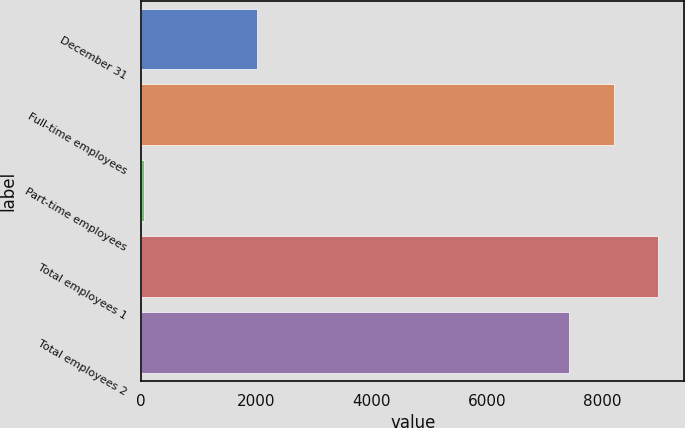Convert chart to OTSL. <chart><loc_0><loc_0><loc_500><loc_500><bar_chart><fcel>December 31<fcel>Full-time employees<fcel>Part-time employees<fcel>Total employees 1<fcel>Total employees 2<nl><fcel>2013<fcel>8208.6<fcel>45<fcel>8982.2<fcel>7435<nl></chart> 